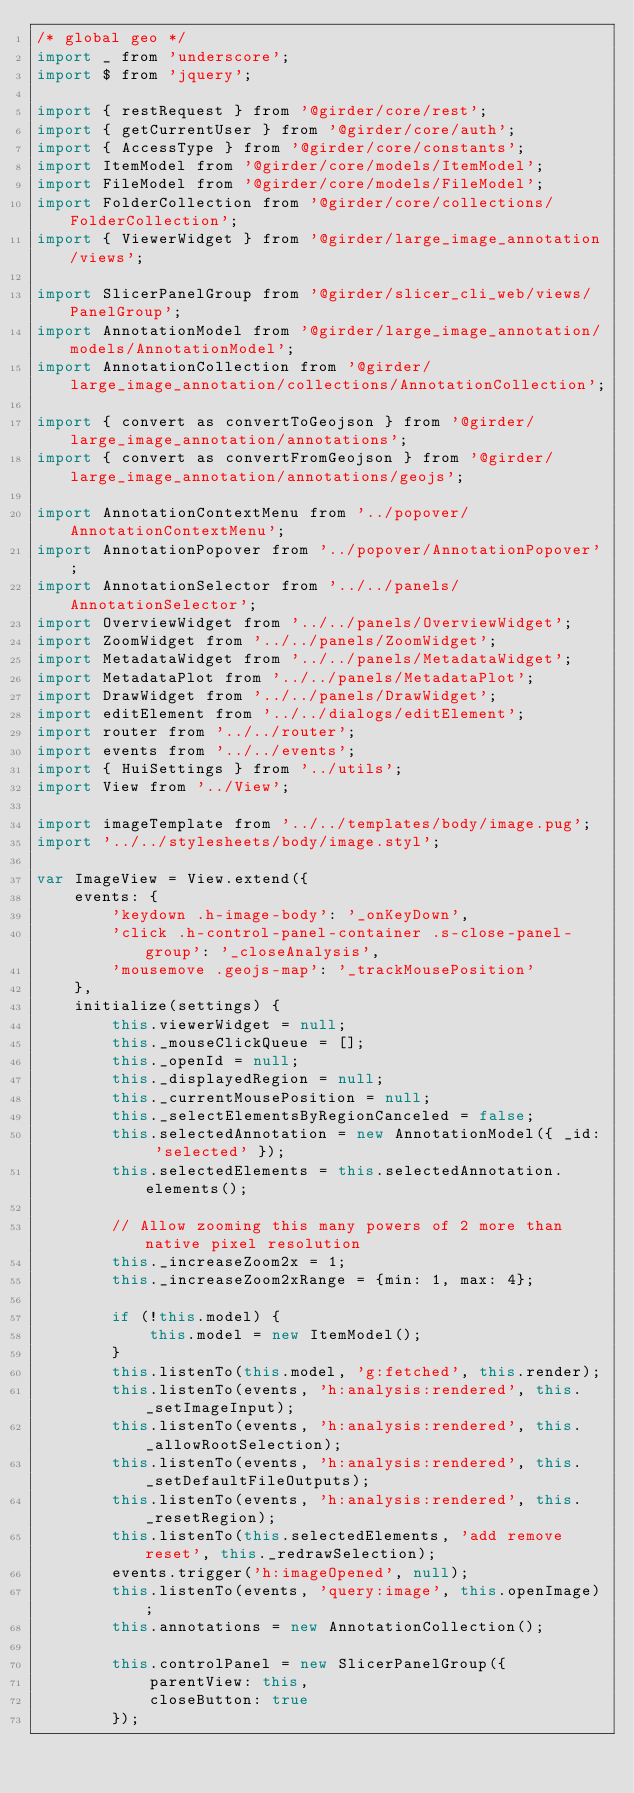<code> <loc_0><loc_0><loc_500><loc_500><_JavaScript_>/* global geo */
import _ from 'underscore';
import $ from 'jquery';

import { restRequest } from '@girder/core/rest';
import { getCurrentUser } from '@girder/core/auth';
import { AccessType } from '@girder/core/constants';
import ItemModel from '@girder/core/models/ItemModel';
import FileModel from '@girder/core/models/FileModel';
import FolderCollection from '@girder/core/collections/FolderCollection';
import { ViewerWidget } from '@girder/large_image_annotation/views';

import SlicerPanelGroup from '@girder/slicer_cli_web/views/PanelGroup';
import AnnotationModel from '@girder/large_image_annotation/models/AnnotationModel';
import AnnotationCollection from '@girder/large_image_annotation/collections/AnnotationCollection';

import { convert as convertToGeojson } from '@girder/large_image_annotation/annotations';
import { convert as convertFromGeojson } from '@girder/large_image_annotation/annotations/geojs';

import AnnotationContextMenu from '../popover/AnnotationContextMenu';
import AnnotationPopover from '../popover/AnnotationPopover';
import AnnotationSelector from '../../panels/AnnotationSelector';
import OverviewWidget from '../../panels/OverviewWidget';
import ZoomWidget from '../../panels/ZoomWidget';
import MetadataWidget from '../../panels/MetadataWidget';
import MetadataPlot from '../../panels/MetadataPlot';
import DrawWidget from '../../panels/DrawWidget';
import editElement from '../../dialogs/editElement';
import router from '../../router';
import events from '../../events';
import { HuiSettings } from '../utils';
import View from '../View';

import imageTemplate from '../../templates/body/image.pug';
import '../../stylesheets/body/image.styl';

var ImageView = View.extend({
    events: {
        'keydown .h-image-body': '_onKeyDown',
        'click .h-control-panel-container .s-close-panel-group': '_closeAnalysis',
        'mousemove .geojs-map': '_trackMousePosition'
    },
    initialize(settings) {
        this.viewerWidget = null;
        this._mouseClickQueue = [];
        this._openId = null;
        this._displayedRegion = null;
        this._currentMousePosition = null;
        this._selectElementsByRegionCanceled = false;
        this.selectedAnnotation = new AnnotationModel({ _id: 'selected' });
        this.selectedElements = this.selectedAnnotation.elements();

        // Allow zooming this many powers of 2 more than native pixel resolution
        this._increaseZoom2x = 1;
        this._increaseZoom2xRange = {min: 1, max: 4};

        if (!this.model) {
            this.model = new ItemModel();
        }
        this.listenTo(this.model, 'g:fetched', this.render);
        this.listenTo(events, 'h:analysis:rendered', this._setImageInput);
        this.listenTo(events, 'h:analysis:rendered', this._allowRootSelection);
        this.listenTo(events, 'h:analysis:rendered', this._setDefaultFileOutputs);
        this.listenTo(events, 'h:analysis:rendered', this._resetRegion);
        this.listenTo(this.selectedElements, 'add remove reset', this._redrawSelection);
        events.trigger('h:imageOpened', null);
        this.listenTo(events, 'query:image', this.openImage);
        this.annotations = new AnnotationCollection();

        this.controlPanel = new SlicerPanelGroup({
            parentView: this,
            closeButton: true
        });</code> 